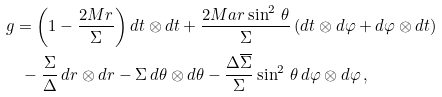Convert formula to latex. <formula><loc_0><loc_0><loc_500><loc_500>& g = \left ( 1 - \frac { 2 M r } { \Sigma } \right ) d t \otimes d t + \frac { 2 M a r \sin ^ { 2 } \, \theta } { \Sigma } \, ( d t \otimes d \varphi + d \varphi \otimes d t ) \\ & \quad - \frac { \Sigma } { \Delta } \, d r \otimes d r - \Sigma \, d \theta \otimes d \theta - \frac { \Delta \overline { \Sigma } } { \Sigma } \sin ^ { 2 } \, \theta \, d \varphi \otimes d \varphi \, ,</formula> 